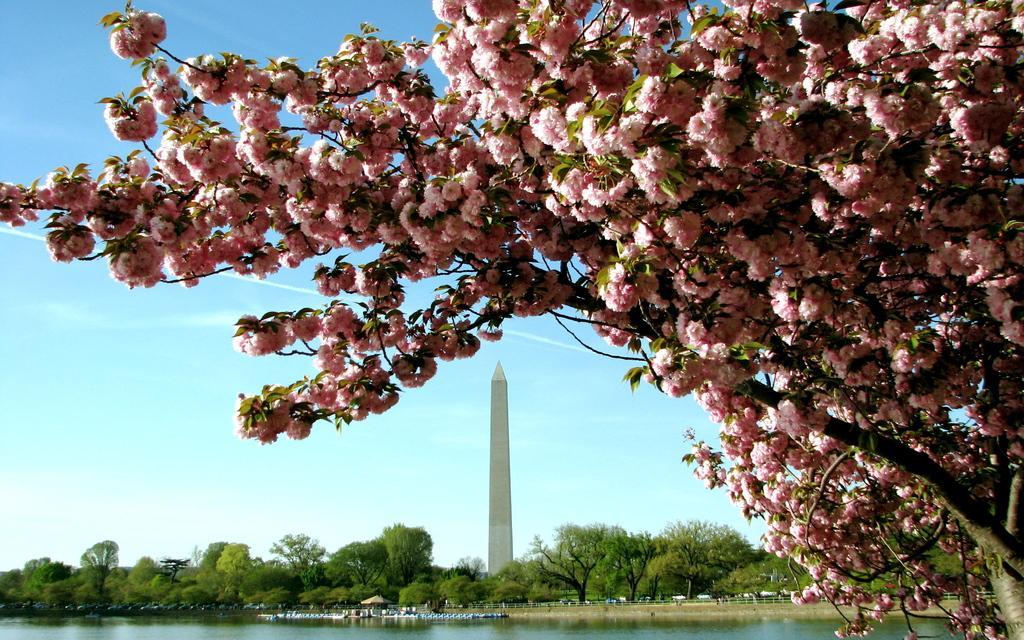Could you give a brief overview of what you see in this image? This is a tree with the flowers, which are light pink in color. This looks like a tower. I can see the water flowing. These are the trees. 